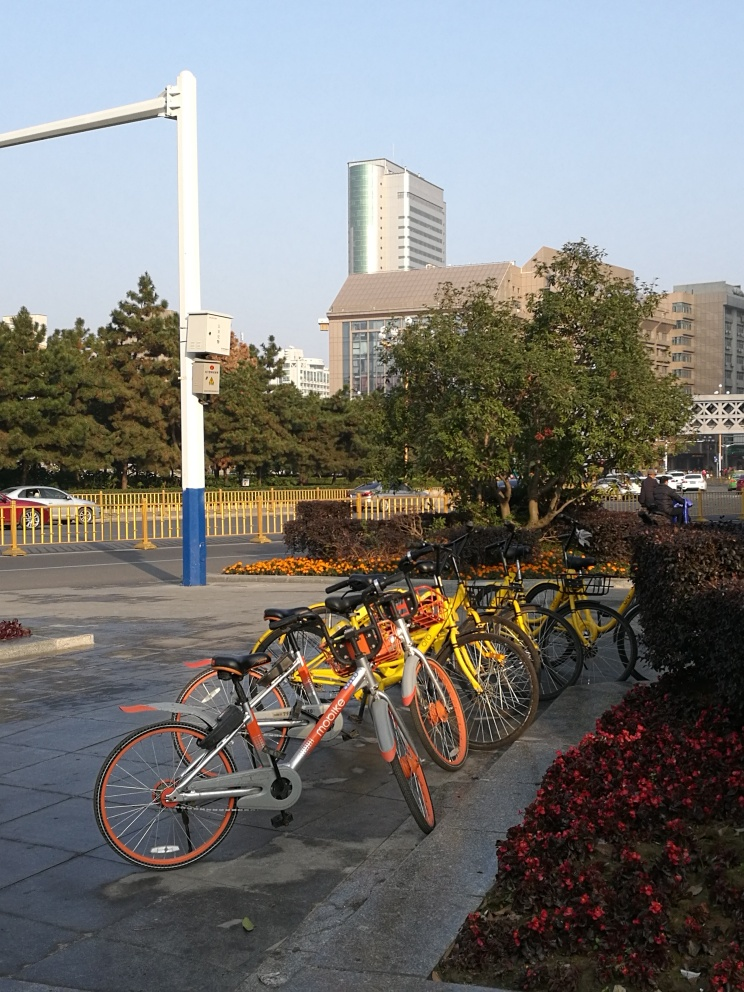Can you tell me more about the area in this photo? Certainly! The photo includes a row of parked bicycles and electric scooters, suggesting a bike-sharing service common in urban areas. There's a mixture of foliage, like well-maintained shrubs and trees, alongside a paved sidewalk. The background shows a variety of buildings that indicate a mixed-use area with commercial and residential properties. It seems to be a well-organized and possibly busy area during peak hours. 